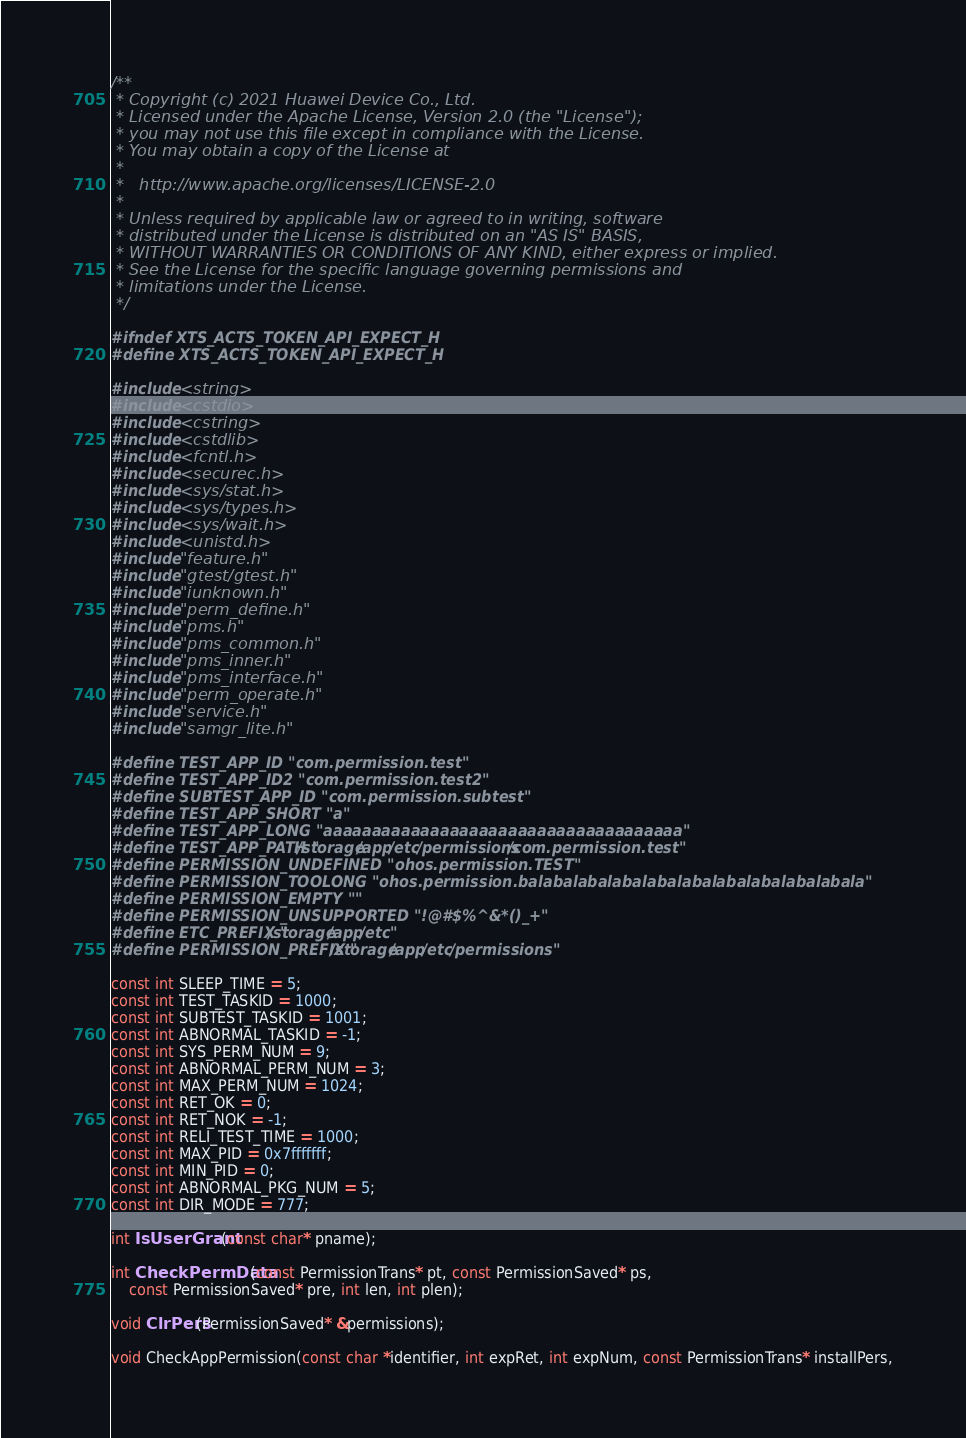Convert code to text. <code><loc_0><loc_0><loc_500><loc_500><_C_>/**
 * Copyright (c) 2021 Huawei Device Co., Ltd.
 * Licensed under the Apache License, Version 2.0 (the "License");
 * you may not use this file except in compliance with the License.
 * You may obtain a copy of the License at
 *
 *   http://www.apache.org/licenses/LICENSE-2.0
 *
 * Unless required by applicable law or agreed to in writing, software
 * distributed under the License is distributed on an "AS IS" BASIS,
 * WITHOUT WARRANTIES OR CONDITIONS OF ANY KIND, either express or implied.
 * See the License for the specific language governing permissions and
 * limitations under the License.
 */

#ifndef XTS_ACTS_TOKEN_API_EXPECT_H
#define XTS_ACTS_TOKEN_API_EXPECT_H

#include <string>
#include <cstdio>
#include <cstring>
#include <cstdlib>
#include <fcntl.h>
#include <securec.h>
#include <sys/stat.h>
#include <sys/types.h>
#include <sys/wait.h>
#include <unistd.h>
#include "feature.h"
#include "gtest/gtest.h"
#include "iunknown.h"
#include "perm_define.h"
#include "pms.h"
#include "pms_common.h"
#include "pms_inner.h"
#include "pms_interface.h"
#include "perm_operate.h"
#include "service.h"
#include "samgr_lite.h"

#define TEST_APP_ID "com.permission.test"
#define TEST_APP_ID2 "com.permission.test2"
#define SUBTEST_APP_ID "com.permission.subtest"
#define TEST_APP_SHORT "a"
#define TEST_APP_LONG "aaaaaaaaaaaaaaaaaaaaaaaaaaaaaaaaaaaaa"
#define TEST_APP_PATH "/storage/app/etc/permissions/com.permission.test"
#define PERMISSION_UNDEFINED "ohos.permission.TEST"
#define PERMISSION_TOOLONG "ohos.permission.balabalabalabalabalabalabalabalabalabala"
#define PERMISSION_EMPTY ""
#define PERMISSION_UNSUPPORTED "!@#$%^&*()_+"
#define ETC_PREFIX "/storage/app/etc"
#define PERMISSION_PREFIX "/storage/app/etc/permissions"

const int SLEEP_TIME = 5;
const int TEST_TASKID = 1000;
const int SUBTEST_TASKID = 1001;
const int ABNORMAL_TASKID = -1;
const int SYS_PERM_NUM = 9;
const int ABNORMAL_PERM_NUM = 3;
const int MAX_PERM_NUM = 1024;
const int RET_OK = 0;
const int RET_NOK = -1;
const int RELI_TEST_TIME = 1000;
const int MAX_PID = 0x7fffffff;
const int MIN_PID = 0;
const int ABNORMAL_PKG_NUM = 5;
const int DIR_MODE = 777;

int IsUserGrant(const char* pname);

int CheckPermData(const PermissionTrans* pt, const PermissionSaved* ps,
    const PermissionSaved* pre, int len, int plen);

void ClrPers(PermissionSaved* &permissions);

void CheckAppPermission(const char *identifier, int expRet, int expNum, const PermissionTrans* installPers,</code> 